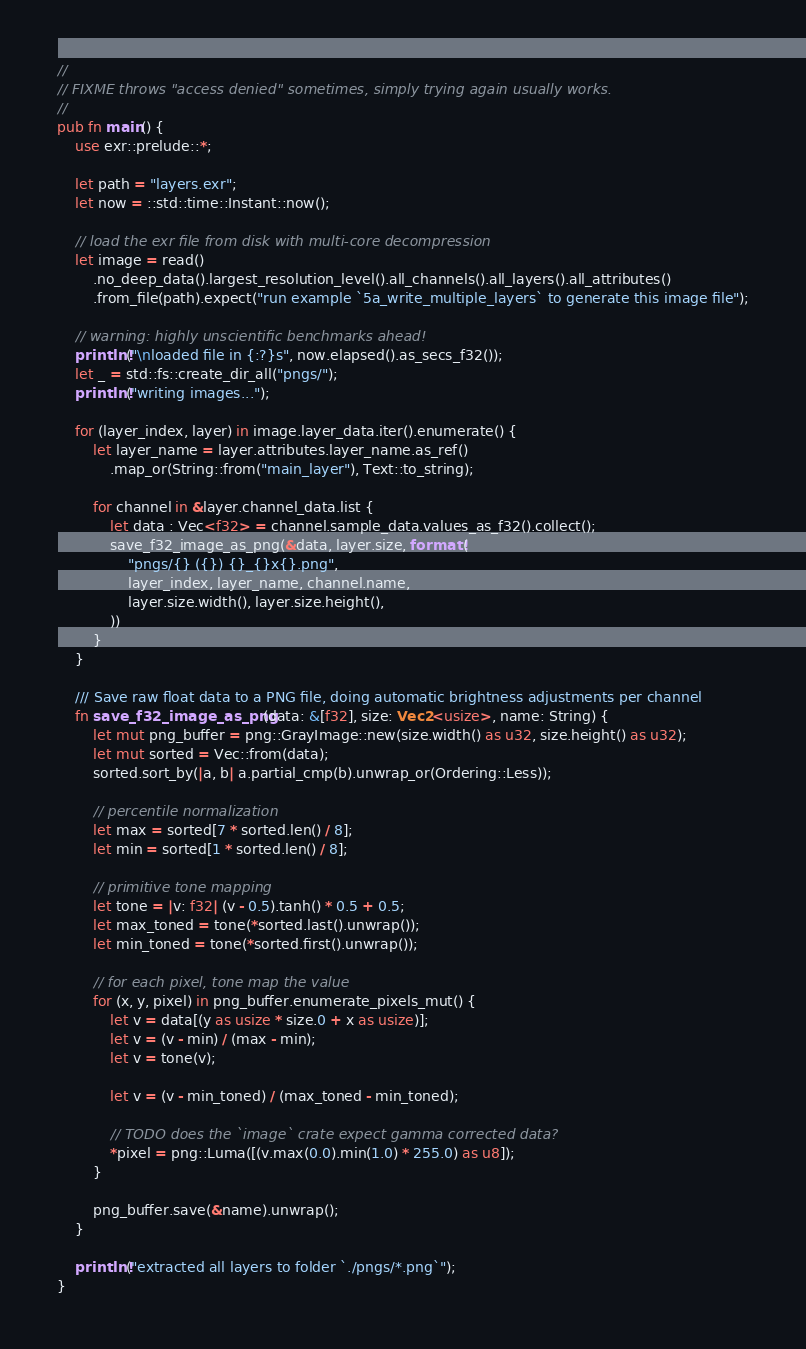Convert code to text. <code><loc_0><loc_0><loc_500><loc_500><_Rust_>//
// FIXME throws "access denied" sometimes, simply trying again usually works.
//
pub fn main() {
    use exr::prelude::*;

    let path = "layers.exr";
    let now = ::std::time::Instant::now();

    // load the exr file from disk with multi-core decompression
    let image = read()
        .no_deep_data().largest_resolution_level().all_channels().all_layers().all_attributes()
        .from_file(path).expect("run example `5a_write_multiple_layers` to generate this image file");

    // warning: highly unscientific benchmarks ahead!
    println!("\nloaded file in {:?}s", now.elapsed().as_secs_f32());
    let _ = std::fs::create_dir_all("pngs/");
    println!("writing images...");

    for (layer_index, layer) in image.layer_data.iter().enumerate() {
        let layer_name = layer.attributes.layer_name.as_ref()
            .map_or(String::from("main_layer"), Text::to_string);

        for channel in &layer.channel_data.list {
            let data : Vec<f32> = channel.sample_data.values_as_f32().collect();
            save_f32_image_as_png(&data, layer.size, format!(
                "pngs/{} ({}) {}_{}x{}.png",
                layer_index, layer_name, channel.name,
                layer.size.width(), layer.size.height(),
            ))
        }
    }

    /// Save raw float data to a PNG file, doing automatic brightness adjustments per channel
    fn save_f32_image_as_png(data: &[f32], size: Vec2<usize>, name: String) {
        let mut png_buffer = png::GrayImage::new(size.width() as u32, size.height() as u32);
        let mut sorted = Vec::from(data);
        sorted.sort_by(|a, b| a.partial_cmp(b).unwrap_or(Ordering::Less));

        // percentile normalization
        let max = sorted[7 * sorted.len() / 8];
        let min = sorted[1 * sorted.len() / 8];

        // primitive tone mapping
        let tone = |v: f32| (v - 0.5).tanh() * 0.5 + 0.5;
        let max_toned = tone(*sorted.last().unwrap());
        let min_toned = tone(*sorted.first().unwrap());

        // for each pixel, tone map the value
        for (x, y, pixel) in png_buffer.enumerate_pixels_mut() {
            let v = data[(y as usize * size.0 + x as usize)];
            let v = (v - min) / (max - min);
            let v = tone(v);

            let v = (v - min_toned) / (max_toned - min_toned);

            // TODO does the `image` crate expect gamma corrected data?
            *pixel = png::Luma([(v.max(0.0).min(1.0) * 255.0) as u8]);
        }

        png_buffer.save(&name).unwrap();
    }

    println!("extracted all layers to folder `./pngs/*.png`");
}

</code> 